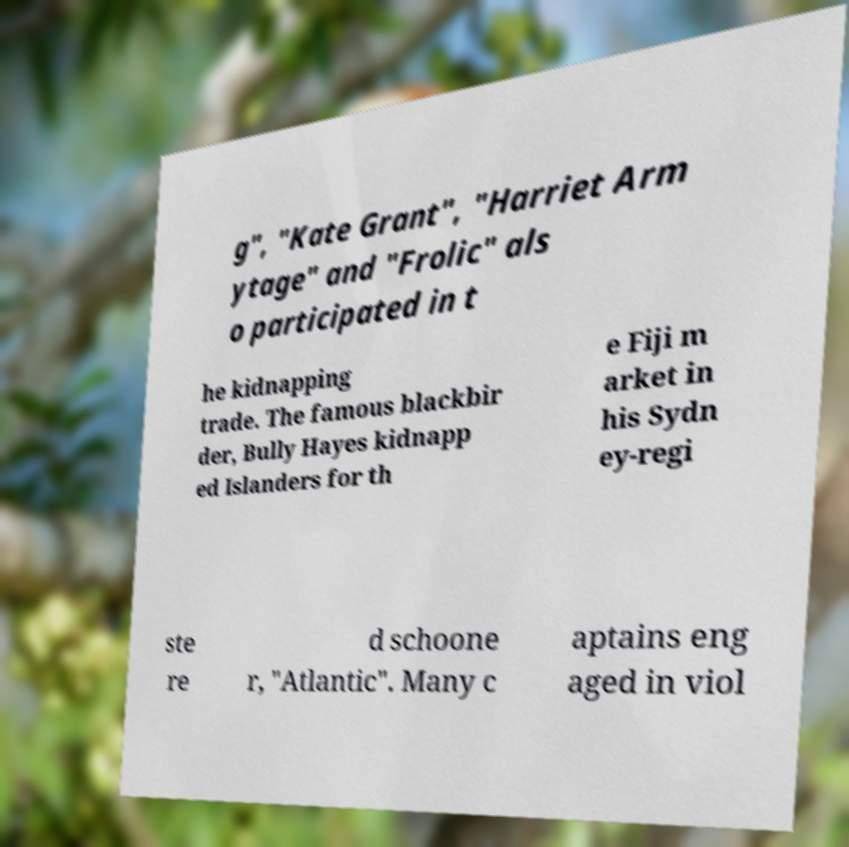There's text embedded in this image that I need extracted. Can you transcribe it verbatim? g", "Kate Grant", "Harriet Arm ytage" and "Frolic" als o participated in t he kidnapping trade. The famous blackbir der, Bully Hayes kidnapp ed Islanders for th e Fiji m arket in his Sydn ey-regi ste re d schoone r, "Atlantic". Many c aptains eng aged in viol 